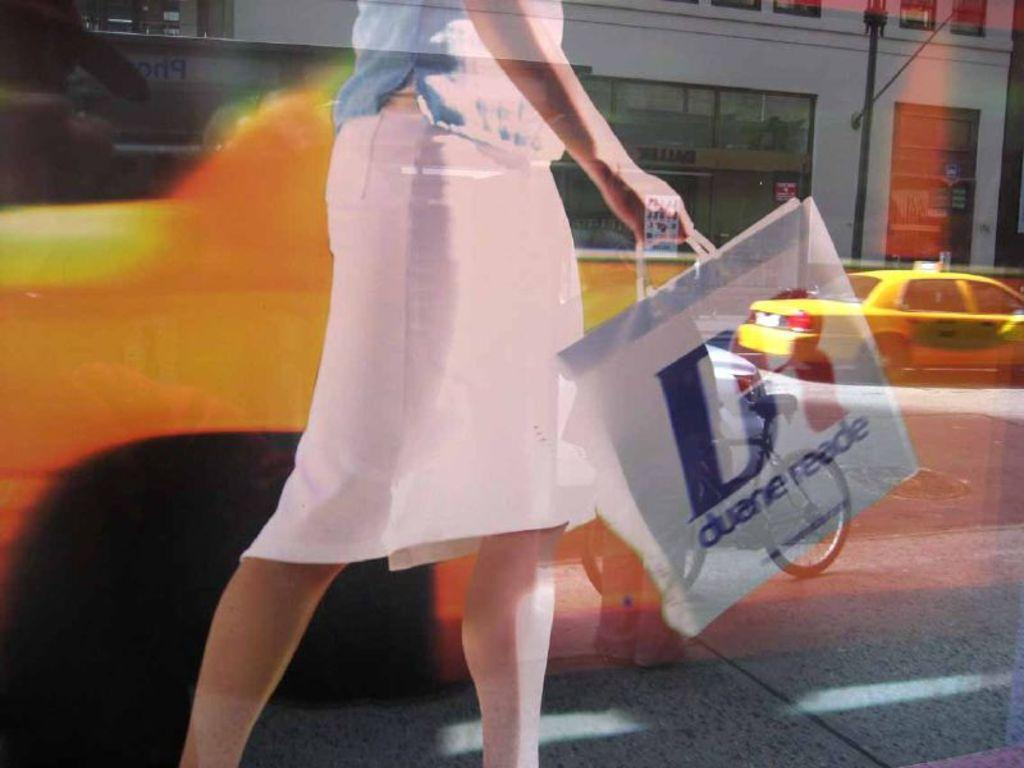<image>
Write a terse but informative summary of the picture. a duene reade bag that is white in color 